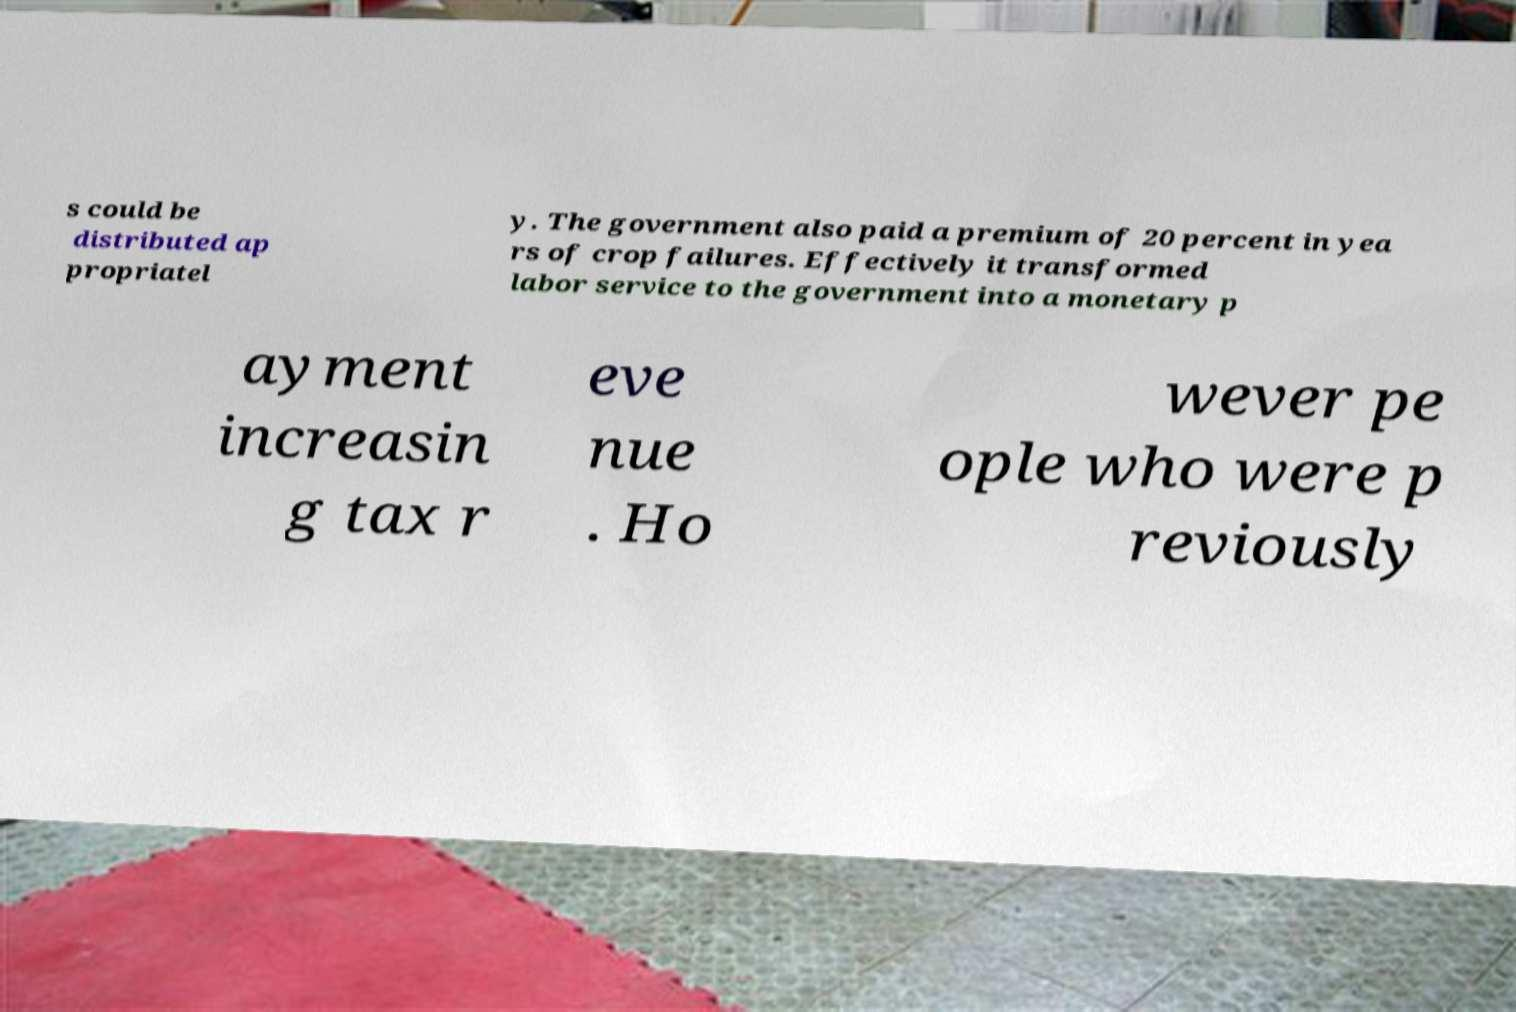Could you assist in decoding the text presented in this image and type it out clearly? s could be distributed ap propriatel y. The government also paid a premium of 20 percent in yea rs of crop failures. Effectively it transformed labor service to the government into a monetary p ayment increasin g tax r eve nue . Ho wever pe ople who were p reviously 